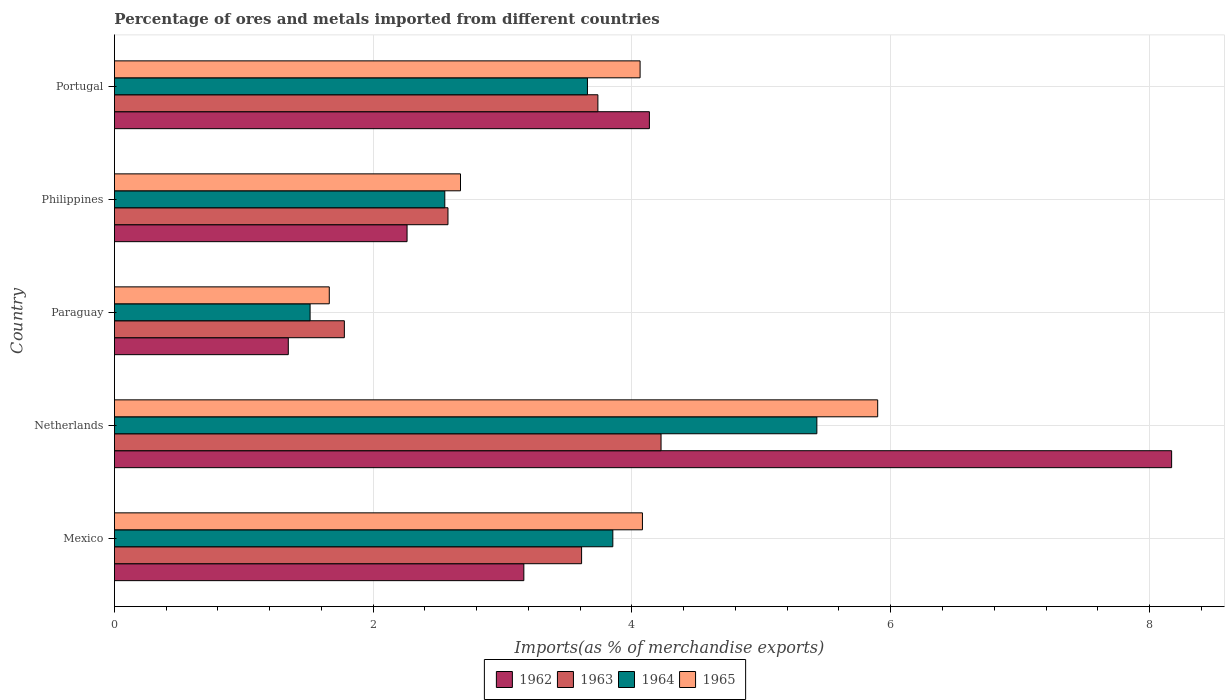How many groups of bars are there?
Keep it short and to the point. 5. How many bars are there on the 4th tick from the top?
Offer a very short reply. 4. How many bars are there on the 5th tick from the bottom?
Offer a very short reply. 4. What is the label of the 5th group of bars from the top?
Keep it short and to the point. Mexico. In how many cases, is the number of bars for a given country not equal to the number of legend labels?
Make the answer very short. 0. What is the percentage of imports to different countries in 1962 in Philippines?
Your answer should be compact. 2.26. Across all countries, what is the maximum percentage of imports to different countries in 1965?
Provide a succinct answer. 5.9. Across all countries, what is the minimum percentage of imports to different countries in 1964?
Keep it short and to the point. 1.51. In which country was the percentage of imports to different countries in 1963 minimum?
Keep it short and to the point. Paraguay. What is the total percentage of imports to different countries in 1965 in the graph?
Make the answer very short. 18.38. What is the difference between the percentage of imports to different countries in 1963 in Mexico and that in Paraguay?
Offer a very short reply. 1.83. What is the difference between the percentage of imports to different countries in 1964 in Portugal and the percentage of imports to different countries in 1963 in Philippines?
Your response must be concise. 1.08. What is the average percentage of imports to different countries in 1965 per country?
Your response must be concise. 3.68. What is the difference between the percentage of imports to different countries in 1964 and percentage of imports to different countries in 1962 in Portugal?
Your answer should be very brief. -0.48. What is the ratio of the percentage of imports to different countries in 1963 in Mexico to that in Portugal?
Give a very brief answer. 0.97. What is the difference between the highest and the second highest percentage of imports to different countries in 1965?
Offer a very short reply. 1.82. What is the difference between the highest and the lowest percentage of imports to different countries in 1962?
Provide a succinct answer. 6.83. In how many countries, is the percentage of imports to different countries in 1962 greater than the average percentage of imports to different countries in 1962 taken over all countries?
Keep it short and to the point. 2. Is the sum of the percentage of imports to different countries in 1964 in Netherlands and Philippines greater than the maximum percentage of imports to different countries in 1963 across all countries?
Offer a terse response. Yes. Is it the case that in every country, the sum of the percentage of imports to different countries in 1963 and percentage of imports to different countries in 1962 is greater than the sum of percentage of imports to different countries in 1964 and percentage of imports to different countries in 1965?
Give a very brief answer. No. What does the 3rd bar from the top in Mexico represents?
Ensure brevity in your answer.  1963. What does the 3rd bar from the bottom in Philippines represents?
Make the answer very short. 1964. Are all the bars in the graph horizontal?
Keep it short and to the point. Yes. How many countries are there in the graph?
Your response must be concise. 5. What is the difference between two consecutive major ticks on the X-axis?
Provide a succinct answer. 2. Are the values on the major ticks of X-axis written in scientific E-notation?
Provide a short and direct response. No. Does the graph contain any zero values?
Offer a very short reply. No. How are the legend labels stacked?
Provide a succinct answer. Horizontal. What is the title of the graph?
Ensure brevity in your answer.  Percentage of ores and metals imported from different countries. Does "1960" appear as one of the legend labels in the graph?
Ensure brevity in your answer.  No. What is the label or title of the X-axis?
Your answer should be very brief. Imports(as % of merchandise exports). What is the Imports(as % of merchandise exports) in 1962 in Mexico?
Provide a short and direct response. 3.16. What is the Imports(as % of merchandise exports) in 1963 in Mexico?
Offer a terse response. 3.61. What is the Imports(as % of merchandise exports) in 1964 in Mexico?
Make the answer very short. 3.85. What is the Imports(as % of merchandise exports) in 1965 in Mexico?
Keep it short and to the point. 4.08. What is the Imports(as % of merchandise exports) in 1962 in Netherlands?
Ensure brevity in your answer.  8.17. What is the Imports(as % of merchandise exports) in 1963 in Netherlands?
Give a very brief answer. 4.22. What is the Imports(as % of merchandise exports) of 1964 in Netherlands?
Provide a succinct answer. 5.43. What is the Imports(as % of merchandise exports) of 1965 in Netherlands?
Offer a very short reply. 5.9. What is the Imports(as % of merchandise exports) of 1962 in Paraguay?
Keep it short and to the point. 1.34. What is the Imports(as % of merchandise exports) in 1963 in Paraguay?
Give a very brief answer. 1.78. What is the Imports(as % of merchandise exports) of 1964 in Paraguay?
Your answer should be compact. 1.51. What is the Imports(as % of merchandise exports) in 1965 in Paraguay?
Offer a terse response. 1.66. What is the Imports(as % of merchandise exports) in 1962 in Philippines?
Give a very brief answer. 2.26. What is the Imports(as % of merchandise exports) in 1963 in Philippines?
Your response must be concise. 2.58. What is the Imports(as % of merchandise exports) of 1964 in Philippines?
Ensure brevity in your answer.  2.55. What is the Imports(as % of merchandise exports) in 1965 in Philippines?
Make the answer very short. 2.67. What is the Imports(as % of merchandise exports) in 1962 in Portugal?
Your response must be concise. 4.13. What is the Imports(as % of merchandise exports) in 1963 in Portugal?
Keep it short and to the point. 3.74. What is the Imports(as % of merchandise exports) of 1964 in Portugal?
Offer a very short reply. 3.66. What is the Imports(as % of merchandise exports) in 1965 in Portugal?
Provide a succinct answer. 4.06. Across all countries, what is the maximum Imports(as % of merchandise exports) of 1962?
Your answer should be compact. 8.17. Across all countries, what is the maximum Imports(as % of merchandise exports) in 1963?
Make the answer very short. 4.22. Across all countries, what is the maximum Imports(as % of merchandise exports) of 1964?
Keep it short and to the point. 5.43. Across all countries, what is the maximum Imports(as % of merchandise exports) of 1965?
Ensure brevity in your answer.  5.9. Across all countries, what is the minimum Imports(as % of merchandise exports) of 1962?
Your answer should be compact. 1.34. Across all countries, what is the minimum Imports(as % of merchandise exports) of 1963?
Your answer should be compact. 1.78. Across all countries, what is the minimum Imports(as % of merchandise exports) of 1964?
Make the answer very short. 1.51. Across all countries, what is the minimum Imports(as % of merchandise exports) of 1965?
Your answer should be compact. 1.66. What is the total Imports(as % of merchandise exports) in 1962 in the graph?
Ensure brevity in your answer.  19.08. What is the total Imports(as % of merchandise exports) of 1963 in the graph?
Provide a succinct answer. 15.93. What is the total Imports(as % of merchandise exports) in 1964 in the graph?
Give a very brief answer. 17. What is the total Imports(as % of merchandise exports) of 1965 in the graph?
Ensure brevity in your answer.  18.38. What is the difference between the Imports(as % of merchandise exports) in 1962 in Mexico and that in Netherlands?
Provide a succinct answer. -5.01. What is the difference between the Imports(as % of merchandise exports) in 1963 in Mexico and that in Netherlands?
Offer a terse response. -0.61. What is the difference between the Imports(as % of merchandise exports) of 1964 in Mexico and that in Netherlands?
Make the answer very short. -1.58. What is the difference between the Imports(as % of merchandise exports) of 1965 in Mexico and that in Netherlands?
Offer a very short reply. -1.82. What is the difference between the Imports(as % of merchandise exports) of 1962 in Mexico and that in Paraguay?
Your answer should be compact. 1.82. What is the difference between the Imports(as % of merchandise exports) of 1963 in Mexico and that in Paraguay?
Your answer should be very brief. 1.83. What is the difference between the Imports(as % of merchandise exports) in 1964 in Mexico and that in Paraguay?
Offer a terse response. 2.34. What is the difference between the Imports(as % of merchandise exports) of 1965 in Mexico and that in Paraguay?
Give a very brief answer. 2.42. What is the difference between the Imports(as % of merchandise exports) in 1962 in Mexico and that in Philippines?
Your answer should be very brief. 0.9. What is the difference between the Imports(as % of merchandise exports) of 1963 in Mexico and that in Philippines?
Offer a terse response. 1.03. What is the difference between the Imports(as % of merchandise exports) in 1964 in Mexico and that in Philippines?
Provide a short and direct response. 1.3. What is the difference between the Imports(as % of merchandise exports) of 1965 in Mexico and that in Philippines?
Offer a very short reply. 1.41. What is the difference between the Imports(as % of merchandise exports) of 1962 in Mexico and that in Portugal?
Keep it short and to the point. -0.97. What is the difference between the Imports(as % of merchandise exports) in 1963 in Mexico and that in Portugal?
Offer a terse response. -0.13. What is the difference between the Imports(as % of merchandise exports) of 1964 in Mexico and that in Portugal?
Ensure brevity in your answer.  0.2. What is the difference between the Imports(as % of merchandise exports) in 1965 in Mexico and that in Portugal?
Provide a succinct answer. 0.02. What is the difference between the Imports(as % of merchandise exports) of 1962 in Netherlands and that in Paraguay?
Ensure brevity in your answer.  6.83. What is the difference between the Imports(as % of merchandise exports) in 1963 in Netherlands and that in Paraguay?
Your answer should be very brief. 2.45. What is the difference between the Imports(as % of merchandise exports) of 1964 in Netherlands and that in Paraguay?
Offer a terse response. 3.92. What is the difference between the Imports(as % of merchandise exports) of 1965 in Netherlands and that in Paraguay?
Keep it short and to the point. 4.24. What is the difference between the Imports(as % of merchandise exports) of 1962 in Netherlands and that in Philippines?
Offer a very short reply. 5.91. What is the difference between the Imports(as % of merchandise exports) of 1963 in Netherlands and that in Philippines?
Ensure brevity in your answer.  1.65. What is the difference between the Imports(as % of merchandise exports) in 1964 in Netherlands and that in Philippines?
Provide a short and direct response. 2.88. What is the difference between the Imports(as % of merchandise exports) in 1965 in Netherlands and that in Philippines?
Keep it short and to the point. 3.22. What is the difference between the Imports(as % of merchandise exports) of 1962 in Netherlands and that in Portugal?
Make the answer very short. 4.04. What is the difference between the Imports(as % of merchandise exports) of 1963 in Netherlands and that in Portugal?
Your answer should be very brief. 0.49. What is the difference between the Imports(as % of merchandise exports) of 1964 in Netherlands and that in Portugal?
Offer a very short reply. 1.77. What is the difference between the Imports(as % of merchandise exports) of 1965 in Netherlands and that in Portugal?
Keep it short and to the point. 1.84. What is the difference between the Imports(as % of merchandise exports) of 1962 in Paraguay and that in Philippines?
Offer a terse response. -0.92. What is the difference between the Imports(as % of merchandise exports) of 1963 in Paraguay and that in Philippines?
Offer a terse response. -0.8. What is the difference between the Imports(as % of merchandise exports) in 1964 in Paraguay and that in Philippines?
Give a very brief answer. -1.04. What is the difference between the Imports(as % of merchandise exports) of 1965 in Paraguay and that in Philippines?
Ensure brevity in your answer.  -1.01. What is the difference between the Imports(as % of merchandise exports) of 1962 in Paraguay and that in Portugal?
Your answer should be very brief. -2.79. What is the difference between the Imports(as % of merchandise exports) of 1963 in Paraguay and that in Portugal?
Give a very brief answer. -1.96. What is the difference between the Imports(as % of merchandise exports) of 1964 in Paraguay and that in Portugal?
Your response must be concise. -2.14. What is the difference between the Imports(as % of merchandise exports) of 1965 in Paraguay and that in Portugal?
Make the answer very short. -2.4. What is the difference between the Imports(as % of merchandise exports) of 1962 in Philippines and that in Portugal?
Ensure brevity in your answer.  -1.87. What is the difference between the Imports(as % of merchandise exports) in 1963 in Philippines and that in Portugal?
Ensure brevity in your answer.  -1.16. What is the difference between the Imports(as % of merchandise exports) of 1964 in Philippines and that in Portugal?
Offer a very short reply. -1.1. What is the difference between the Imports(as % of merchandise exports) in 1965 in Philippines and that in Portugal?
Your response must be concise. -1.39. What is the difference between the Imports(as % of merchandise exports) in 1962 in Mexico and the Imports(as % of merchandise exports) in 1963 in Netherlands?
Ensure brevity in your answer.  -1.06. What is the difference between the Imports(as % of merchandise exports) in 1962 in Mexico and the Imports(as % of merchandise exports) in 1964 in Netherlands?
Your response must be concise. -2.26. What is the difference between the Imports(as % of merchandise exports) of 1962 in Mexico and the Imports(as % of merchandise exports) of 1965 in Netherlands?
Provide a succinct answer. -2.73. What is the difference between the Imports(as % of merchandise exports) of 1963 in Mexico and the Imports(as % of merchandise exports) of 1964 in Netherlands?
Your response must be concise. -1.82. What is the difference between the Imports(as % of merchandise exports) of 1963 in Mexico and the Imports(as % of merchandise exports) of 1965 in Netherlands?
Offer a very short reply. -2.29. What is the difference between the Imports(as % of merchandise exports) of 1964 in Mexico and the Imports(as % of merchandise exports) of 1965 in Netherlands?
Make the answer very short. -2.05. What is the difference between the Imports(as % of merchandise exports) in 1962 in Mexico and the Imports(as % of merchandise exports) in 1963 in Paraguay?
Ensure brevity in your answer.  1.39. What is the difference between the Imports(as % of merchandise exports) of 1962 in Mexico and the Imports(as % of merchandise exports) of 1964 in Paraguay?
Your answer should be compact. 1.65. What is the difference between the Imports(as % of merchandise exports) of 1962 in Mexico and the Imports(as % of merchandise exports) of 1965 in Paraguay?
Offer a terse response. 1.5. What is the difference between the Imports(as % of merchandise exports) in 1963 in Mexico and the Imports(as % of merchandise exports) in 1964 in Paraguay?
Give a very brief answer. 2.1. What is the difference between the Imports(as % of merchandise exports) in 1963 in Mexico and the Imports(as % of merchandise exports) in 1965 in Paraguay?
Offer a terse response. 1.95. What is the difference between the Imports(as % of merchandise exports) of 1964 in Mexico and the Imports(as % of merchandise exports) of 1965 in Paraguay?
Ensure brevity in your answer.  2.19. What is the difference between the Imports(as % of merchandise exports) of 1962 in Mexico and the Imports(as % of merchandise exports) of 1963 in Philippines?
Make the answer very short. 0.59. What is the difference between the Imports(as % of merchandise exports) of 1962 in Mexico and the Imports(as % of merchandise exports) of 1964 in Philippines?
Your answer should be compact. 0.61. What is the difference between the Imports(as % of merchandise exports) in 1962 in Mexico and the Imports(as % of merchandise exports) in 1965 in Philippines?
Offer a terse response. 0.49. What is the difference between the Imports(as % of merchandise exports) of 1963 in Mexico and the Imports(as % of merchandise exports) of 1964 in Philippines?
Make the answer very short. 1.06. What is the difference between the Imports(as % of merchandise exports) in 1963 in Mexico and the Imports(as % of merchandise exports) in 1965 in Philippines?
Make the answer very short. 0.94. What is the difference between the Imports(as % of merchandise exports) in 1964 in Mexico and the Imports(as % of merchandise exports) in 1965 in Philippines?
Your response must be concise. 1.18. What is the difference between the Imports(as % of merchandise exports) of 1962 in Mexico and the Imports(as % of merchandise exports) of 1963 in Portugal?
Your answer should be very brief. -0.57. What is the difference between the Imports(as % of merchandise exports) in 1962 in Mexico and the Imports(as % of merchandise exports) in 1964 in Portugal?
Offer a terse response. -0.49. What is the difference between the Imports(as % of merchandise exports) of 1962 in Mexico and the Imports(as % of merchandise exports) of 1965 in Portugal?
Your answer should be compact. -0.9. What is the difference between the Imports(as % of merchandise exports) in 1963 in Mexico and the Imports(as % of merchandise exports) in 1964 in Portugal?
Provide a short and direct response. -0.05. What is the difference between the Imports(as % of merchandise exports) in 1963 in Mexico and the Imports(as % of merchandise exports) in 1965 in Portugal?
Keep it short and to the point. -0.45. What is the difference between the Imports(as % of merchandise exports) of 1964 in Mexico and the Imports(as % of merchandise exports) of 1965 in Portugal?
Your answer should be very brief. -0.21. What is the difference between the Imports(as % of merchandise exports) in 1962 in Netherlands and the Imports(as % of merchandise exports) in 1963 in Paraguay?
Make the answer very short. 6.39. What is the difference between the Imports(as % of merchandise exports) of 1962 in Netherlands and the Imports(as % of merchandise exports) of 1964 in Paraguay?
Give a very brief answer. 6.66. What is the difference between the Imports(as % of merchandise exports) in 1962 in Netherlands and the Imports(as % of merchandise exports) in 1965 in Paraguay?
Make the answer very short. 6.51. What is the difference between the Imports(as % of merchandise exports) in 1963 in Netherlands and the Imports(as % of merchandise exports) in 1964 in Paraguay?
Offer a terse response. 2.71. What is the difference between the Imports(as % of merchandise exports) in 1963 in Netherlands and the Imports(as % of merchandise exports) in 1965 in Paraguay?
Keep it short and to the point. 2.56. What is the difference between the Imports(as % of merchandise exports) of 1964 in Netherlands and the Imports(as % of merchandise exports) of 1965 in Paraguay?
Keep it short and to the point. 3.77. What is the difference between the Imports(as % of merchandise exports) of 1962 in Netherlands and the Imports(as % of merchandise exports) of 1963 in Philippines?
Offer a very short reply. 5.59. What is the difference between the Imports(as % of merchandise exports) of 1962 in Netherlands and the Imports(as % of merchandise exports) of 1964 in Philippines?
Ensure brevity in your answer.  5.62. What is the difference between the Imports(as % of merchandise exports) of 1962 in Netherlands and the Imports(as % of merchandise exports) of 1965 in Philippines?
Provide a succinct answer. 5.5. What is the difference between the Imports(as % of merchandise exports) in 1963 in Netherlands and the Imports(as % of merchandise exports) in 1964 in Philippines?
Give a very brief answer. 1.67. What is the difference between the Imports(as % of merchandise exports) in 1963 in Netherlands and the Imports(as % of merchandise exports) in 1965 in Philippines?
Keep it short and to the point. 1.55. What is the difference between the Imports(as % of merchandise exports) in 1964 in Netherlands and the Imports(as % of merchandise exports) in 1965 in Philippines?
Your answer should be very brief. 2.75. What is the difference between the Imports(as % of merchandise exports) of 1962 in Netherlands and the Imports(as % of merchandise exports) of 1963 in Portugal?
Provide a succinct answer. 4.43. What is the difference between the Imports(as % of merchandise exports) of 1962 in Netherlands and the Imports(as % of merchandise exports) of 1964 in Portugal?
Provide a short and direct response. 4.51. What is the difference between the Imports(as % of merchandise exports) in 1962 in Netherlands and the Imports(as % of merchandise exports) in 1965 in Portugal?
Offer a very short reply. 4.11. What is the difference between the Imports(as % of merchandise exports) of 1963 in Netherlands and the Imports(as % of merchandise exports) of 1964 in Portugal?
Offer a very short reply. 0.57. What is the difference between the Imports(as % of merchandise exports) of 1963 in Netherlands and the Imports(as % of merchandise exports) of 1965 in Portugal?
Provide a short and direct response. 0.16. What is the difference between the Imports(as % of merchandise exports) of 1964 in Netherlands and the Imports(as % of merchandise exports) of 1965 in Portugal?
Give a very brief answer. 1.37. What is the difference between the Imports(as % of merchandise exports) in 1962 in Paraguay and the Imports(as % of merchandise exports) in 1963 in Philippines?
Provide a short and direct response. -1.23. What is the difference between the Imports(as % of merchandise exports) in 1962 in Paraguay and the Imports(as % of merchandise exports) in 1964 in Philippines?
Your response must be concise. -1.21. What is the difference between the Imports(as % of merchandise exports) of 1962 in Paraguay and the Imports(as % of merchandise exports) of 1965 in Philippines?
Keep it short and to the point. -1.33. What is the difference between the Imports(as % of merchandise exports) of 1963 in Paraguay and the Imports(as % of merchandise exports) of 1964 in Philippines?
Offer a terse response. -0.78. What is the difference between the Imports(as % of merchandise exports) in 1963 in Paraguay and the Imports(as % of merchandise exports) in 1965 in Philippines?
Provide a short and direct response. -0.9. What is the difference between the Imports(as % of merchandise exports) in 1964 in Paraguay and the Imports(as % of merchandise exports) in 1965 in Philippines?
Offer a very short reply. -1.16. What is the difference between the Imports(as % of merchandise exports) of 1962 in Paraguay and the Imports(as % of merchandise exports) of 1963 in Portugal?
Provide a succinct answer. -2.39. What is the difference between the Imports(as % of merchandise exports) in 1962 in Paraguay and the Imports(as % of merchandise exports) in 1964 in Portugal?
Make the answer very short. -2.31. What is the difference between the Imports(as % of merchandise exports) in 1962 in Paraguay and the Imports(as % of merchandise exports) in 1965 in Portugal?
Offer a very short reply. -2.72. What is the difference between the Imports(as % of merchandise exports) in 1963 in Paraguay and the Imports(as % of merchandise exports) in 1964 in Portugal?
Provide a short and direct response. -1.88. What is the difference between the Imports(as % of merchandise exports) of 1963 in Paraguay and the Imports(as % of merchandise exports) of 1965 in Portugal?
Your response must be concise. -2.29. What is the difference between the Imports(as % of merchandise exports) in 1964 in Paraguay and the Imports(as % of merchandise exports) in 1965 in Portugal?
Offer a terse response. -2.55. What is the difference between the Imports(as % of merchandise exports) of 1962 in Philippines and the Imports(as % of merchandise exports) of 1963 in Portugal?
Ensure brevity in your answer.  -1.47. What is the difference between the Imports(as % of merchandise exports) in 1962 in Philippines and the Imports(as % of merchandise exports) in 1964 in Portugal?
Your answer should be compact. -1.39. What is the difference between the Imports(as % of merchandise exports) of 1962 in Philippines and the Imports(as % of merchandise exports) of 1965 in Portugal?
Offer a very short reply. -1.8. What is the difference between the Imports(as % of merchandise exports) of 1963 in Philippines and the Imports(as % of merchandise exports) of 1964 in Portugal?
Your answer should be very brief. -1.08. What is the difference between the Imports(as % of merchandise exports) in 1963 in Philippines and the Imports(as % of merchandise exports) in 1965 in Portugal?
Offer a very short reply. -1.48. What is the difference between the Imports(as % of merchandise exports) in 1964 in Philippines and the Imports(as % of merchandise exports) in 1965 in Portugal?
Keep it short and to the point. -1.51. What is the average Imports(as % of merchandise exports) in 1962 per country?
Ensure brevity in your answer.  3.82. What is the average Imports(as % of merchandise exports) of 1963 per country?
Ensure brevity in your answer.  3.19. What is the average Imports(as % of merchandise exports) in 1964 per country?
Make the answer very short. 3.4. What is the average Imports(as % of merchandise exports) in 1965 per country?
Keep it short and to the point. 3.68. What is the difference between the Imports(as % of merchandise exports) of 1962 and Imports(as % of merchandise exports) of 1963 in Mexico?
Your answer should be compact. -0.45. What is the difference between the Imports(as % of merchandise exports) of 1962 and Imports(as % of merchandise exports) of 1964 in Mexico?
Provide a succinct answer. -0.69. What is the difference between the Imports(as % of merchandise exports) of 1962 and Imports(as % of merchandise exports) of 1965 in Mexico?
Keep it short and to the point. -0.92. What is the difference between the Imports(as % of merchandise exports) of 1963 and Imports(as % of merchandise exports) of 1964 in Mexico?
Make the answer very short. -0.24. What is the difference between the Imports(as % of merchandise exports) of 1963 and Imports(as % of merchandise exports) of 1965 in Mexico?
Offer a very short reply. -0.47. What is the difference between the Imports(as % of merchandise exports) in 1964 and Imports(as % of merchandise exports) in 1965 in Mexico?
Give a very brief answer. -0.23. What is the difference between the Imports(as % of merchandise exports) in 1962 and Imports(as % of merchandise exports) in 1963 in Netherlands?
Your answer should be very brief. 3.95. What is the difference between the Imports(as % of merchandise exports) of 1962 and Imports(as % of merchandise exports) of 1964 in Netherlands?
Offer a very short reply. 2.74. What is the difference between the Imports(as % of merchandise exports) of 1962 and Imports(as % of merchandise exports) of 1965 in Netherlands?
Offer a very short reply. 2.27. What is the difference between the Imports(as % of merchandise exports) of 1963 and Imports(as % of merchandise exports) of 1964 in Netherlands?
Your answer should be compact. -1.2. What is the difference between the Imports(as % of merchandise exports) of 1963 and Imports(as % of merchandise exports) of 1965 in Netherlands?
Your response must be concise. -1.67. What is the difference between the Imports(as % of merchandise exports) of 1964 and Imports(as % of merchandise exports) of 1965 in Netherlands?
Provide a succinct answer. -0.47. What is the difference between the Imports(as % of merchandise exports) in 1962 and Imports(as % of merchandise exports) in 1963 in Paraguay?
Provide a short and direct response. -0.43. What is the difference between the Imports(as % of merchandise exports) of 1962 and Imports(as % of merchandise exports) of 1964 in Paraguay?
Your answer should be very brief. -0.17. What is the difference between the Imports(as % of merchandise exports) of 1962 and Imports(as % of merchandise exports) of 1965 in Paraguay?
Offer a very short reply. -0.32. What is the difference between the Imports(as % of merchandise exports) in 1963 and Imports(as % of merchandise exports) in 1964 in Paraguay?
Your answer should be compact. 0.26. What is the difference between the Imports(as % of merchandise exports) of 1963 and Imports(as % of merchandise exports) of 1965 in Paraguay?
Provide a short and direct response. 0.12. What is the difference between the Imports(as % of merchandise exports) in 1964 and Imports(as % of merchandise exports) in 1965 in Paraguay?
Keep it short and to the point. -0.15. What is the difference between the Imports(as % of merchandise exports) of 1962 and Imports(as % of merchandise exports) of 1963 in Philippines?
Ensure brevity in your answer.  -0.32. What is the difference between the Imports(as % of merchandise exports) in 1962 and Imports(as % of merchandise exports) in 1964 in Philippines?
Offer a very short reply. -0.29. What is the difference between the Imports(as % of merchandise exports) of 1962 and Imports(as % of merchandise exports) of 1965 in Philippines?
Provide a short and direct response. -0.41. What is the difference between the Imports(as % of merchandise exports) in 1963 and Imports(as % of merchandise exports) in 1964 in Philippines?
Your answer should be very brief. 0.02. What is the difference between the Imports(as % of merchandise exports) in 1963 and Imports(as % of merchandise exports) in 1965 in Philippines?
Your answer should be compact. -0.1. What is the difference between the Imports(as % of merchandise exports) of 1964 and Imports(as % of merchandise exports) of 1965 in Philippines?
Your response must be concise. -0.12. What is the difference between the Imports(as % of merchandise exports) of 1962 and Imports(as % of merchandise exports) of 1963 in Portugal?
Give a very brief answer. 0.4. What is the difference between the Imports(as % of merchandise exports) in 1962 and Imports(as % of merchandise exports) in 1964 in Portugal?
Your response must be concise. 0.48. What is the difference between the Imports(as % of merchandise exports) in 1962 and Imports(as % of merchandise exports) in 1965 in Portugal?
Offer a terse response. 0.07. What is the difference between the Imports(as % of merchandise exports) in 1963 and Imports(as % of merchandise exports) in 1964 in Portugal?
Provide a succinct answer. 0.08. What is the difference between the Imports(as % of merchandise exports) of 1963 and Imports(as % of merchandise exports) of 1965 in Portugal?
Your response must be concise. -0.33. What is the difference between the Imports(as % of merchandise exports) of 1964 and Imports(as % of merchandise exports) of 1965 in Portugal?
Your response must be concise. -0.41. What is the ratio of the Imports(as % of merchandise exports) in 1962 in Mexico to that in Netherlands?
Make the answer very short. 0.39. What is the ratio of the Imports(as % of merchandise exports) of 1963 in Mexico to that in Netherlands?
Ensure brevity in your answer.  0.85. What is the ratio of the Imports(as % of merchandise exports) of 1964 in Mexico to that in Netherlands?
Your answer should be compact. 0.71. What is the ratio of the Imports(as % of merchandise exports) of 1965 in Mexico to that in Netherlands?
Provide a short and direct response. 0.69. What is the ratio of the Imports(as % of merchandise exports) of 1962 in Mexico to that in Paraguay?
Your response must be concise. 2.35. What is the ratio of the Imports(as % of merchandise exports) in 1963 in Mexico to that in Paraguay?
Give a very brief answer. 2.03. What is the ratio of the Imports(as % of merchandise exports) in 1964 in Mexico to that in Paraguay?
Offer a very short reply. 2.55. What is the ratio of the Imports(as % of merchandise exports) in 1965 in Mexico to that in Paraguay?
Provide a succinct answer. 2.46. What is the ratio of the Imports(as % of merchandise exports) of 1962 in Mexico to that in Philippines?
Your answer should be very brief. 1.4. What is the ratio of the Imports(as % of merchandise exports) of 1963 in Mexico to that in Philippines?
Keep it short and to the point. 1.4. What is the ratio of the Imports(as % of merchandise exports) in 1964 in Mexico to that in Philippines?
Your answer should be compact. 1.51. What is the ratio of the Imports(as % of merchandise exports) of 1965 in Mexico to that in Philippines?
Ensure brevity in your answer.  1.53. What is the ratio of the Imports(as % of merchandise exports) in 1962 in Mexico to that in Portugal?
Your answer should be very brief. 0.77. What is the ratio of the Imports(as % of merchandise exports) in 1963 in Mexico to that in Portugal?
Provide a short and direct response. 0.97. What is the ratio of the Imports(as % of merchandise exports) of 1964 in Mexico to that in Portugal?
Offer a very short reply. 1.05. What is the ratio of the Imports(as % of merchandise exports) of 1965 in Mexico to that in Portugal?
Provide a short and direct response. 1. What is the ratio of the Imports(as % of merchandise exports) of 1962 in Netherlands to that in Paraguay?
Your answer should be compact. 6.08. What is the ratio of the Imports(as % of merchandise exports) in 1963 in Netherlands to that in Paraguay?
Give a very brief answer. 2.38. What is the ratio of the Imports(as % of merchandise exports) of 1964 in Netherlands to that in Paraguay?
Offer a terse response. 3.59. What is the ratio of the Imports(as % of merchandise exports) in 1965 in Netherlands to that in Paraguay?
Your answer should be compact. 3.55. What is the ratio of the Imports(as % of merchandise exports) in 1962 in Netherlands to that in Philippines?
Provide a short and direct response. 3.61. What is the ratio of the Imports(as % of merchandise exports) of 1963 in Netherlands to that in Philippines?
Your answer should be compact. 1.64. What is the ratio of the Imports(as % of merchandise exports) of 1964 in Netherlands to that in Philippines?
Provide a short and direct response. 2.13. What is the ratio of the Imports(as % of merchandise exports) in 1965 in Netherlands to that in Philippines?
Your response must be concise. 2.21. What is the ratio of the Imports(as % of merchandise exports) in 1962 in Netherlands to that in Portugal?
Your answer should be compact. 1.98. What is the ratio of the Imports(as % of merchandise exports) of 1963 in Netherlands to that in Portugal?
Ensure brevity in your answer.  1.13. What is the ratio of the Imports(as % of merchandise exports) of 1964 in Netherlands to that in Portugal?
Give a very brief answer. 1.49. What is the ratio of the Imports(as % of merchandise exports) in 1965 in Netherlands to that in Portugal?
Keep it short and to the point. 1.45. What is the ratio of the Imports(as % of merchandise exports) in 1962 in Paraguay to that in Philippines?
Provide a short and direct response. 0.59. What is the ratio of the Imports(as % of merchandise exports) of 1963 in Paraguay to that in Philippines?
Your answer should be very brief. 0.69. What is the ratio of the Imports(as % of merchandise exports) in 1964 in Paraguay to that in Philippines?
Offer a terse response. 0.59. What is the ratio of the Imports(as % of merchandise exports) of 1965 in Paraguay to that in Philippines?
Provide a short and direct response. 0.62. What is the ratio of the Imports(as % of merchandise exports) of 1962 in Paraguay to that in Portugal?
Keep it short and to the point. 0.33. What is the ratio of the Imports(as % of merchandise exports) of 1963 in Paraguay to that in Portugal?
Offer a terse response. 0.48. What is the ratio of the Imports(as % of merchandise exports) in 1964 in Paraguay to that in Portugal?
Provide a short and direct response. 0.41. What is the ratio of the Imports(as % of merchandise exports) in 1965 in Paraguay to that in Portugal?
Your answer should be very brief. 0.41. What is the ratio of the Imports(as % of merchandise exports) in 1962 in Philippines to that in Portugal?
Ensure brevity in your answer.  0.55. What is the ratio of the Imports(as % of merchandise exports) of 1963 in Philippines to that in Portugal?
Your answer should be very brief. 0.69. What is the ratio of the Imports(as % of merchandise exports) of 1964 in Philippines to that in Portugal?
Keep it short and to the point. 0.7. What is the ratio of the Imports(as % of merchandise exports) of 1965 in Philippines to that in Portugal?
Provide a succinct answer. 0.66. What is the difference between the highest and the second highest Imports(as % of merchandise exports) of 1962?
Keep it short and to the point. 4.04. What is the difference between the highest and the second highest Imports(as % of merchandise exports) of 1963?
Your answer should be very brief. 0.49. What is the difference between the highest and the second highest Imports(as % of merchandise exports) in 1964?
Provide a short and direct response. 1.58. What is the difference between the highest and the second highest Imports(as % of merchandise exports) in 1965?
Provide a succinct answer. 1.82. What is the difference between the highest and the lowest Imports(as % of merchandise exports) of 1962?
Offer a terse response. 6.83. What is the difference between the highest and the lowest Imports(as % of merchandise exports) in 1963?
Provide a succinct answer. 2.45. What is the difference between the highest and the lowest Imports(as % of merchandise exports) of 1964?
Give a very brief answer. 3.92. What is the difference between the highest and the lowest Imports(as % of merchandise exports) of 1965?
Offer a very short reply. 4.24. 